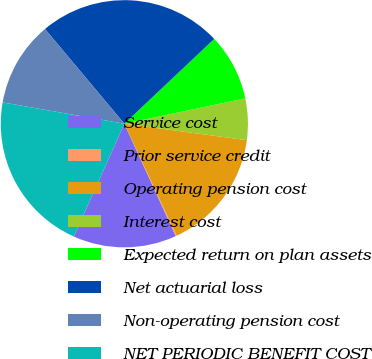<chart> <loc_0><loc_0><loc_500><loc_500><pie_chart><fcel>Service cost<fcel>Prior service credit<fcel>Operating pension cost<fcel>Interest cost<fcel>Expected return on plan assets<fcel>Net actuarial loss<fcel>Non-operating pension cost<fcel>NET PERIODIC BENEFIT COST<nl><fcel>13.54%<fcel>0.12%<fcel>15.93%<fcel>5.41%<fcel>8.75%<fcel>24.06%<fcel>11.14%<fcel>21.06%<nl></chart> 